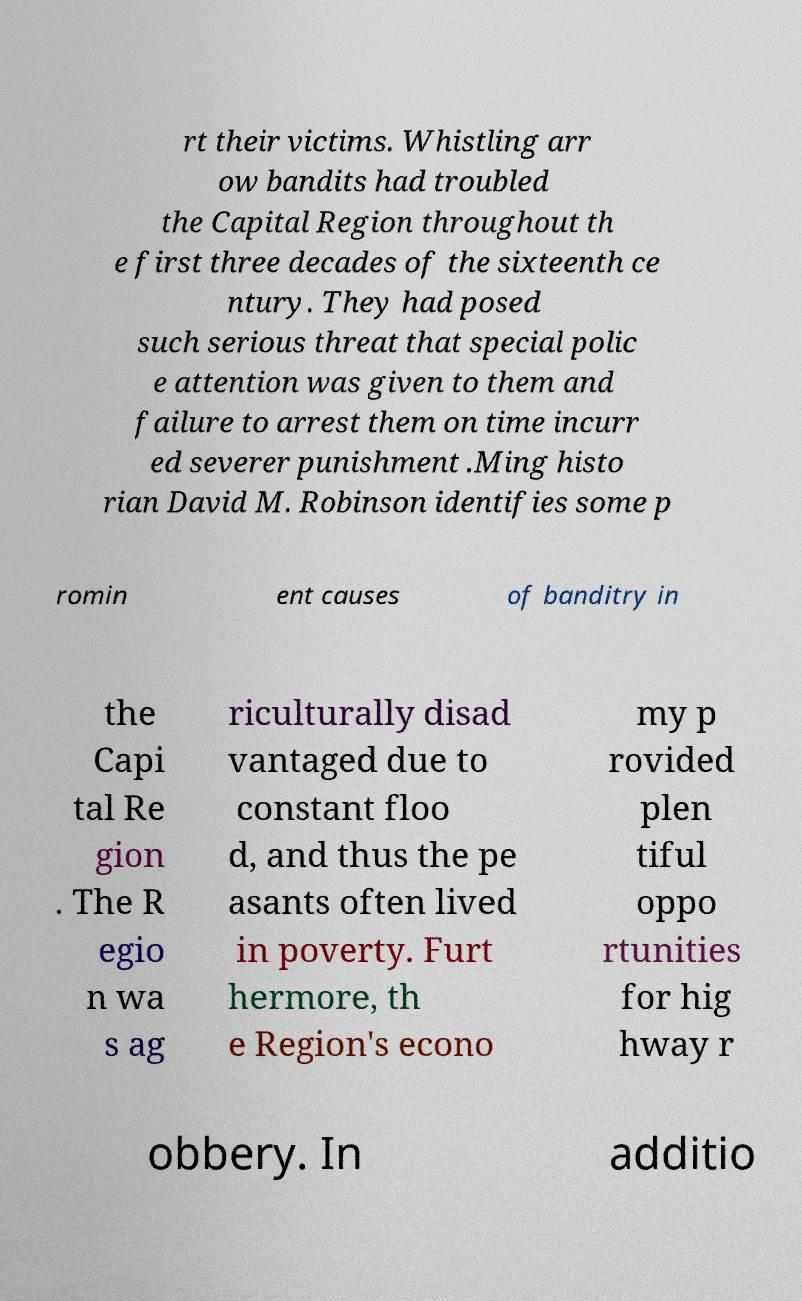Could you assist in decoding the text presented in this image and type it out clearly? rt their victims. Whistling arr ow bandits had troubled the Capital Region throughout th e first three decades of the sixteenth ce ntury. They had posed such serious threat that special polic e attention was given to them and failure to arrest them on time incurr ed severer punishment .Ming histo rian David M. Robinson identifies some p romin ent causes of banditry in the Capi tal Re gion . The R egio n wa s ag riculturally disad vantaged due to constant floo d, and thus the pe asants often lived in poverty. Furt hermore, th e Region's econo my p rovided plen tiful oppo rtunities for hig hway r obbery. In additio 